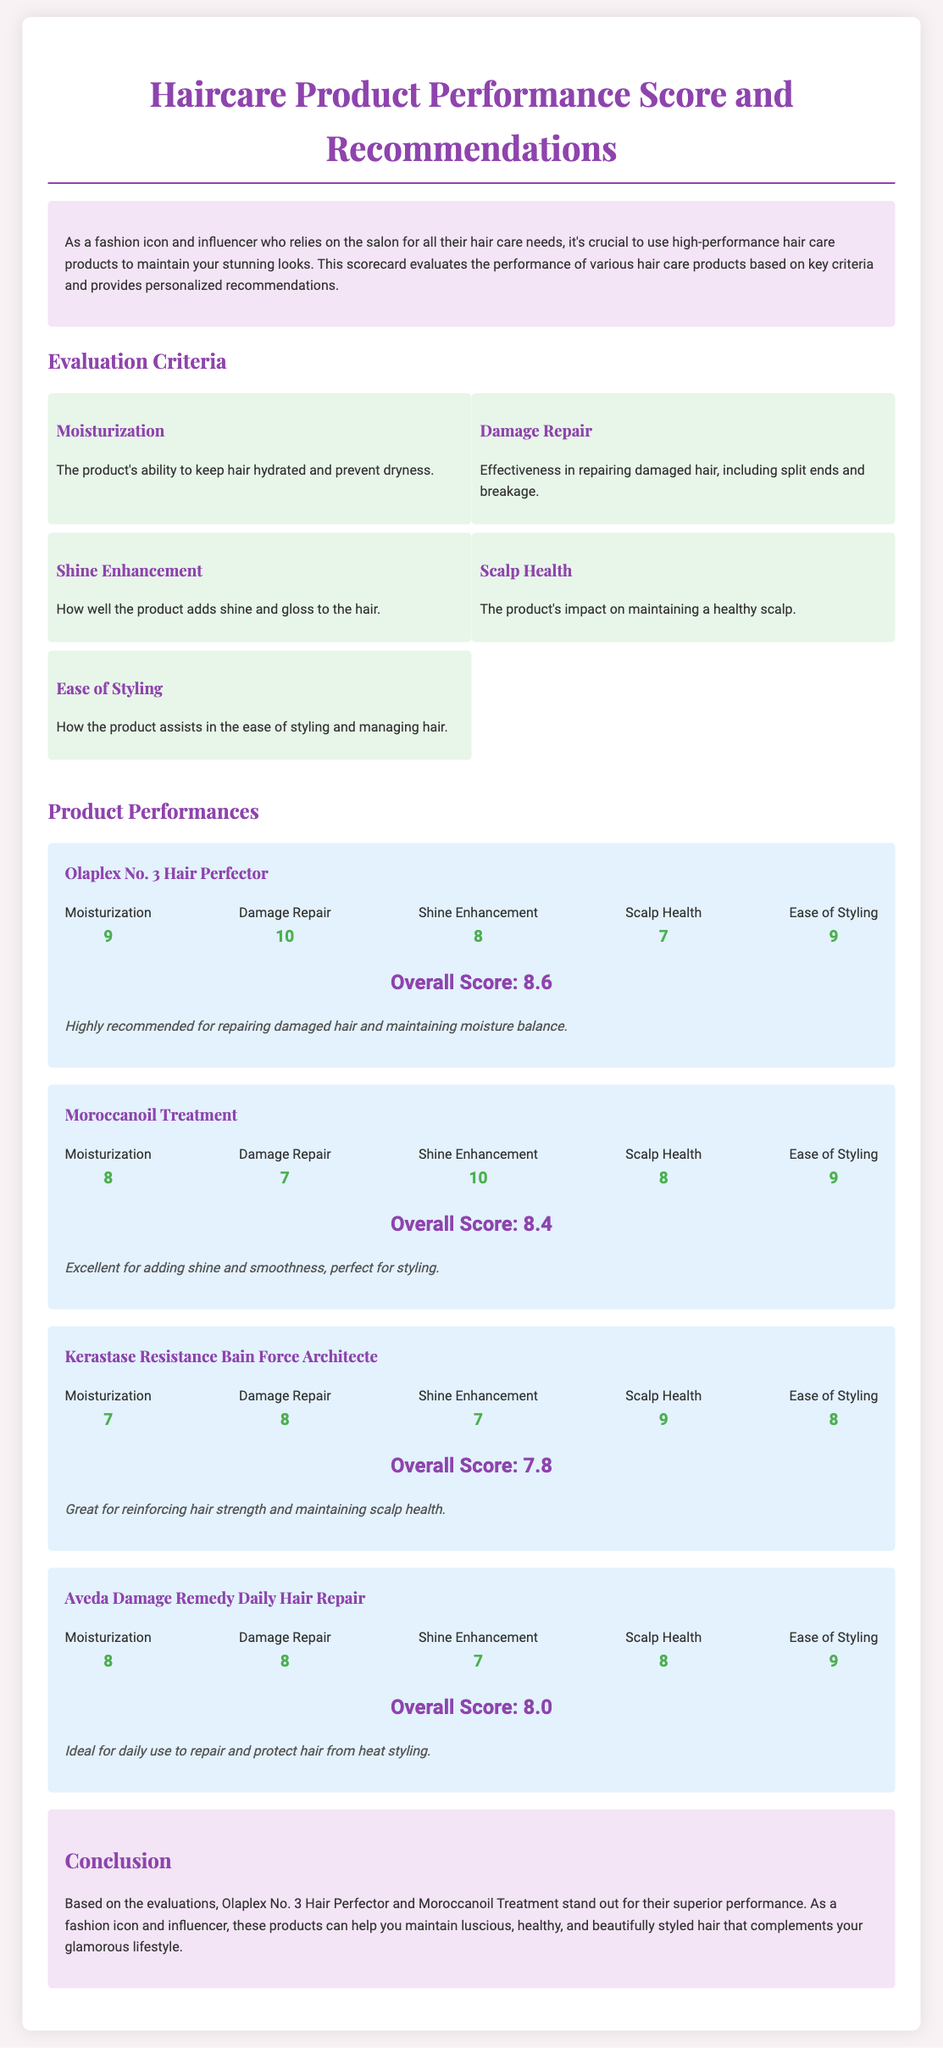What is the overall score of Olaplex No. 3 Hair Perfector? The overall score is found in the product section for Olaplex No. 3 Hair Perfector, which states "Overall Score: 8.6."
Answer: 8.6 What product scored the highest in Damage Repair? The score for Damage Repair is located within the product section, where Olaplex No. 3 Hair Perfector has a score of 10.
Answer: 10 Which product has the lowest score in Shine Enhancement? The scores for Shine Enhancement are compared among products, where Kerastase Resistance Bain Force Architecte has a score of 7.
Answer: 7 What is the recommendation for Moroccanoil Treatment? The recommendation is included in the product section, which states "Excellent for adding shine and smoothness, perfect for styling."
Answer: Excellent for adding shine and smoothness, perfect for styling How many criteria were used to evaluate the products? The number of criteria can be counted from the evaluation criteria section, which lists five distinct criteria.
Answer: 5 What is the evaluation score for Scalp Health of Aveda Damage Remedy Daily Hair Repair? The specific score for Scalp Health is mentioned in Aveda Damage Remedy Daily Hair Repair product section, which shows a score of 8.
Answer: 8 Which product is highlighted for maintaining scalp health? The conclusion section summarizes the recommendations, indicating Kerastase Resistance Bain Force Architecte as great for maintaining scalp health.
Answer: Great for reinforcing hair strength and maintaining scalp health Which product has the second-highest overall score? The overall scores summary shows that Moroccanoil Treatment with a score of 8.4 is the second-highest after Olaplex No. 3 Hair Perfector.
Answer: 8.4 